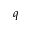Convert formula to latex. <formula><loc_0><loc_0><loc_500><loc_500>q</formula> 